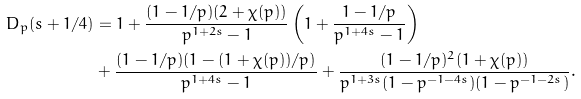Convert formula to latex. <formula><loc_0><loc_0><loc_500><loc_500>D _ { p } ( s + 1 / 4 ) & = 1 + \frac { ( 1 - 1 / p ) ( 2 + \chi ( p ) ) } { p ^ { 1 + 2 s } - 1 } \left ( 1 + \frac { 1 - 1 / p } { p ^ { 1 + 4 s } - 1 } \right ) \\ & + \frac { ( 1 - 1 / p ) ( 1 - ( 1 + \chi ( p ) ) / p ) } { p ^ { 1 + 4 s } - 1 } + \frac { ( 1 - 1 / p ) ^ { 2 } ( 1 + \chi ( p ) ) } { p ^ { 1 + 3 s } ( 1 - p ^ { - 1 - 4 s } ) ( 1 - p ^ { - 1 - 2 s } ) } .</formula> 